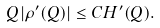Convert formula to latex. <formula><loc_0><loc_0><loc_500><loc_500>Q | \rho ^ { \prime } ( Q ) | \leq C H ^ { \prime } ( Q ) .</formula> 